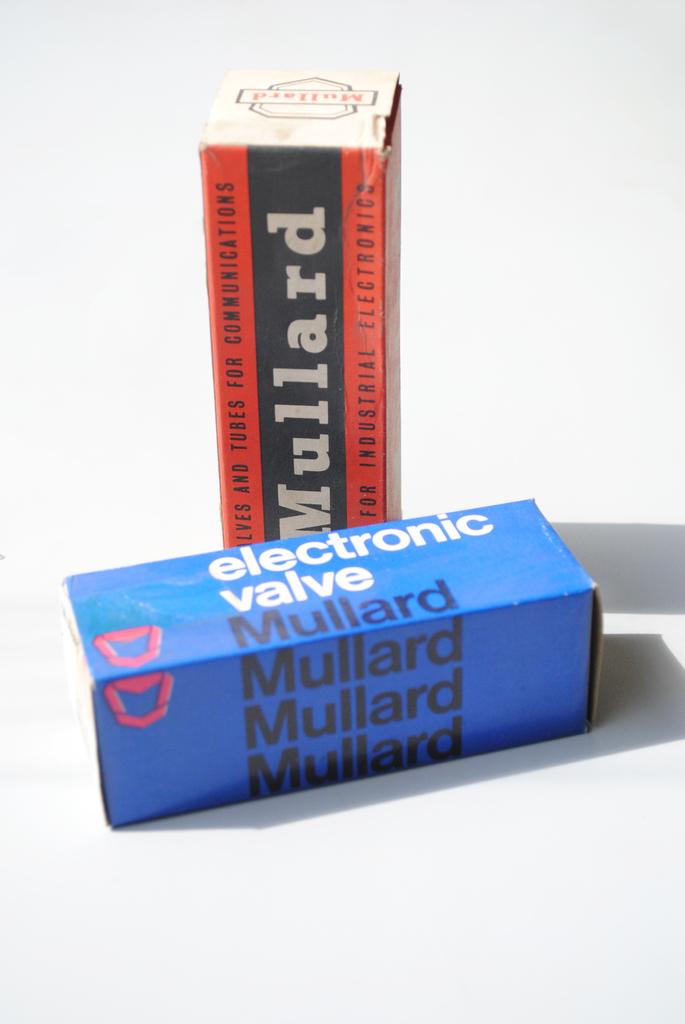What kind of valve is in the blue box?
Your answer should be compact. Electronic. What is the brand name?
Offer a very short reply. Mullard. 